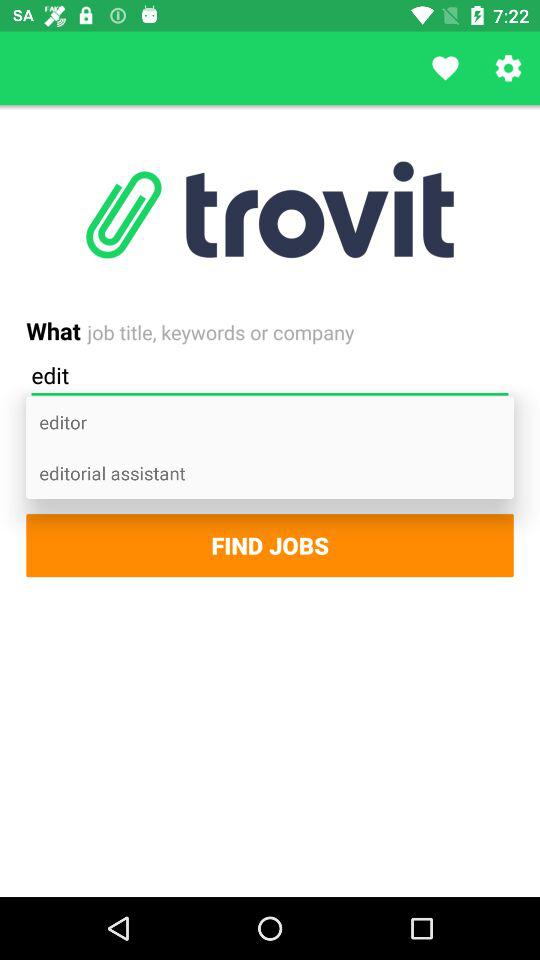What is the application name? The application name is "trovit". 